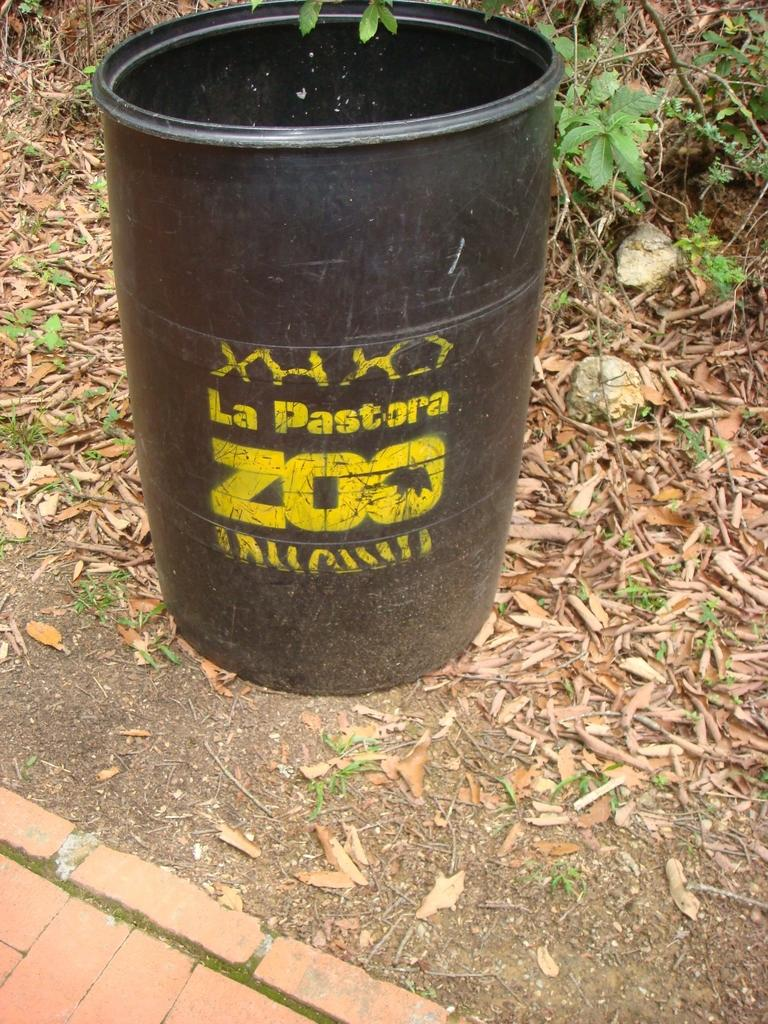<image>
Present a compact description of the photo's key features. A large black barrel that reads "La Pastora Zoo" sitting next to a brick walkway. 